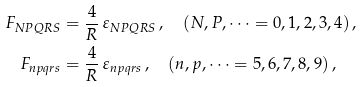Convert formula to latex. <formula><loc_0><loc_0><loc_500><loc_500>F _ { N P Q R S } & = \frac { 4 } { R } \, \varepsilon _ { N P Q R S } \, , \quad ( N , P , \dots = 0 , 1 , 2 , 3 , 4 ) \, , \\ F _ { n p q r s } & = \frac { 4 } { R } \, \varepsilon _ { n p q r s } \, , \quad ( n , p , \dots = 5 , 6 , 7 , 8 , 9 ) \, ,</formula> 